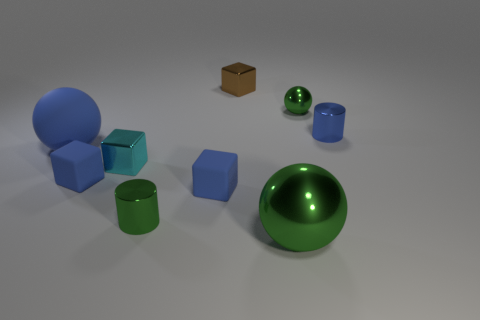There is a large blue object; does it have the same shape as the small green thing in front of the blue cylinder?
Offer a very short reply. No. Is the number of small matte blocks left of the cyan cube less than the number of large purple shiny spheres?
Your answer should be very brief. No. Are there any big green balls in front of the big matte ball?
Your answer should be compact. Yes. Is there a blue matte thing that has the same shape as the large metallic thing?
Ensure brevity in your answer.  Yes. There is a blue metal object that is the same size as the cyan metallic thing; what is its shape?
Provide a short and direct response. Cylinder. How many objects are big things behind the big green metal sphere or blue matte blocks?
Offer a terse response. 3. Does the rubber sphere have the same color as the big metallic sphere?
Make the answer very short. No. There is a cylinder in front of the tiny cyan metal block; how big is it?
Your answer should be very brief. Small. Is there a blue shiny object of the same size as the blue rubber sphere?
Offer a terse response. No. Do the cylinder that is to the right of the brown metallic cube and the tiny shiny sphere have the same size?
Give a very brief answer. Yes. 